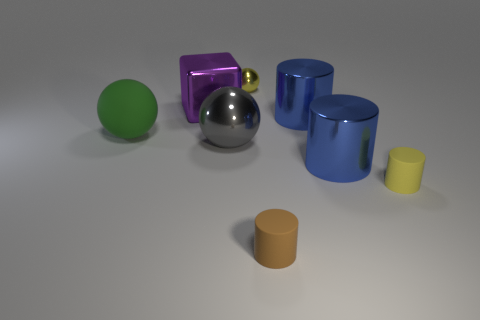There is a tiny thing that is the same color as the small metallic sphere; what is its material?
Provide a succinct answer. Rubber. Are there any purple things of the same size as the brown cylinder?
Provide a short and direct response. No. How many big brown metal spheres are there?
Offer a very short reply. 0. There is a tiny yellow sphere; how many large green rubber things are behind it?
Ensure brevity in your answer.  0. Is the large purple cube made of the same material as the green sphere?
Make the answer very short. No. What number of things are both in front of the tiny metal object and on the right side of the purple metal object?
Provide a succinct answer. 5. How many other objects are the same color as the tiny ball?
Give a very brief answer. 1. How many purple objects are either tiny shiny spheres or large shiny things?
Offer a terse response. 1. What is the size of the yellow matte thing?
Offer a terse response. Small. What number of matte objects are either large brown things or gray balls?
Keep it short and to the point. 0. 